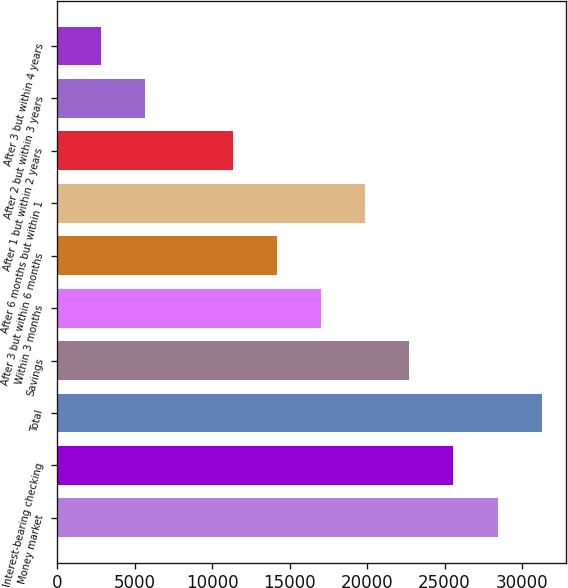<chart> <loc_0><loc_0><loc_500><loc_500><bar_chart><fcel>Money market<fcel>Interest-bearing checking<fcel>Total<fcel>Savings<fcel>Within 3 months<fcel>After 3 but within 6 months<fcel>After 6 months but within 1<fcel>After 1 but within 2 years<fcel>After 2 but within 3 years<fcel>After 3 but within 4 years<nl><fcel>28417.4<fcel>25575.7<fcel>31259.1<fcel>22734<fcel>17050.6<fcel>14208.9<fcel>19892.3<fcel>11367.1<fcel>5683.72<fcel>2842.01<nl></chart> 